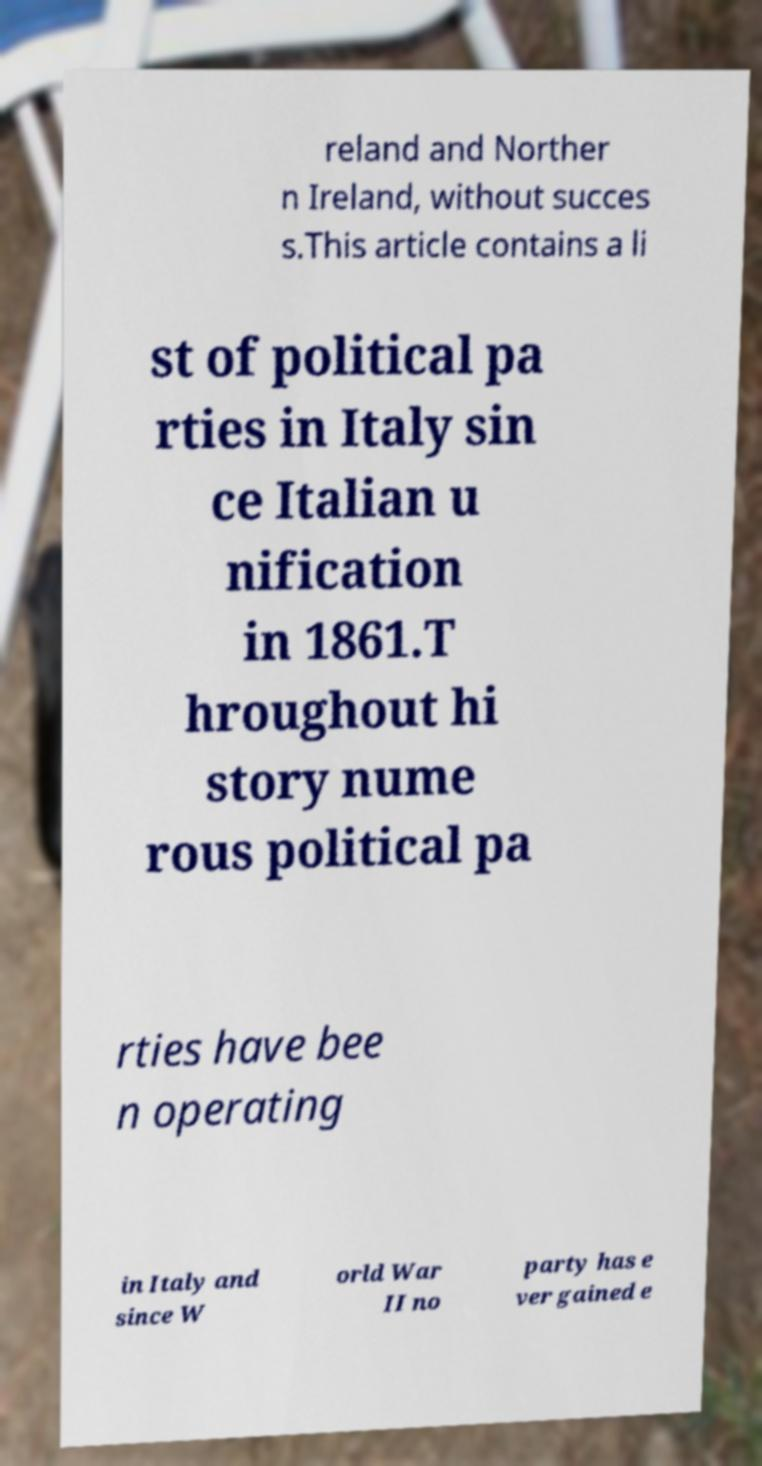Could you assist in decoding the text presented in this image and type it out clearly? reland and Norther n Ireland, without succes s.This article contains a li st of political pa rties in Italy sin ce Italian u nification in 1861.T hroughout hi story nume rous political pa rties have bee n operating in Italy and since W orld War II no party has e ver gained e 